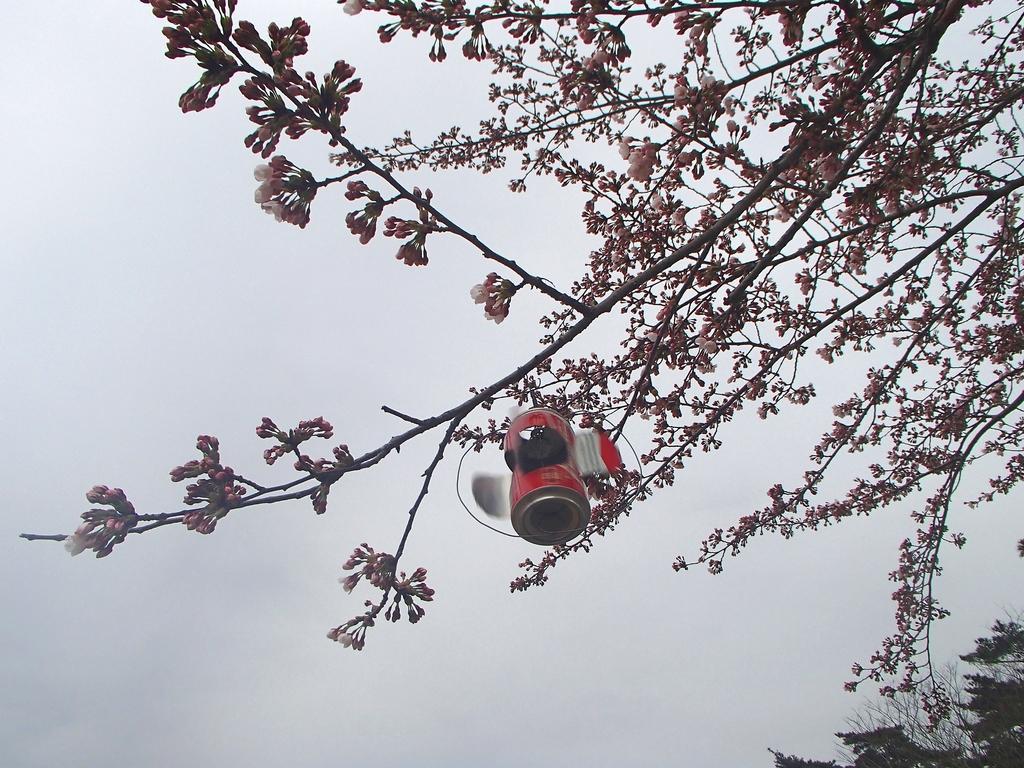In one or two sentences, can you explain what this image depicts? This image is taken outdoors. On the right sides of the image there are a few trees. In the background there is a sky with clouds. In the middle of the image there is a drone camera. 